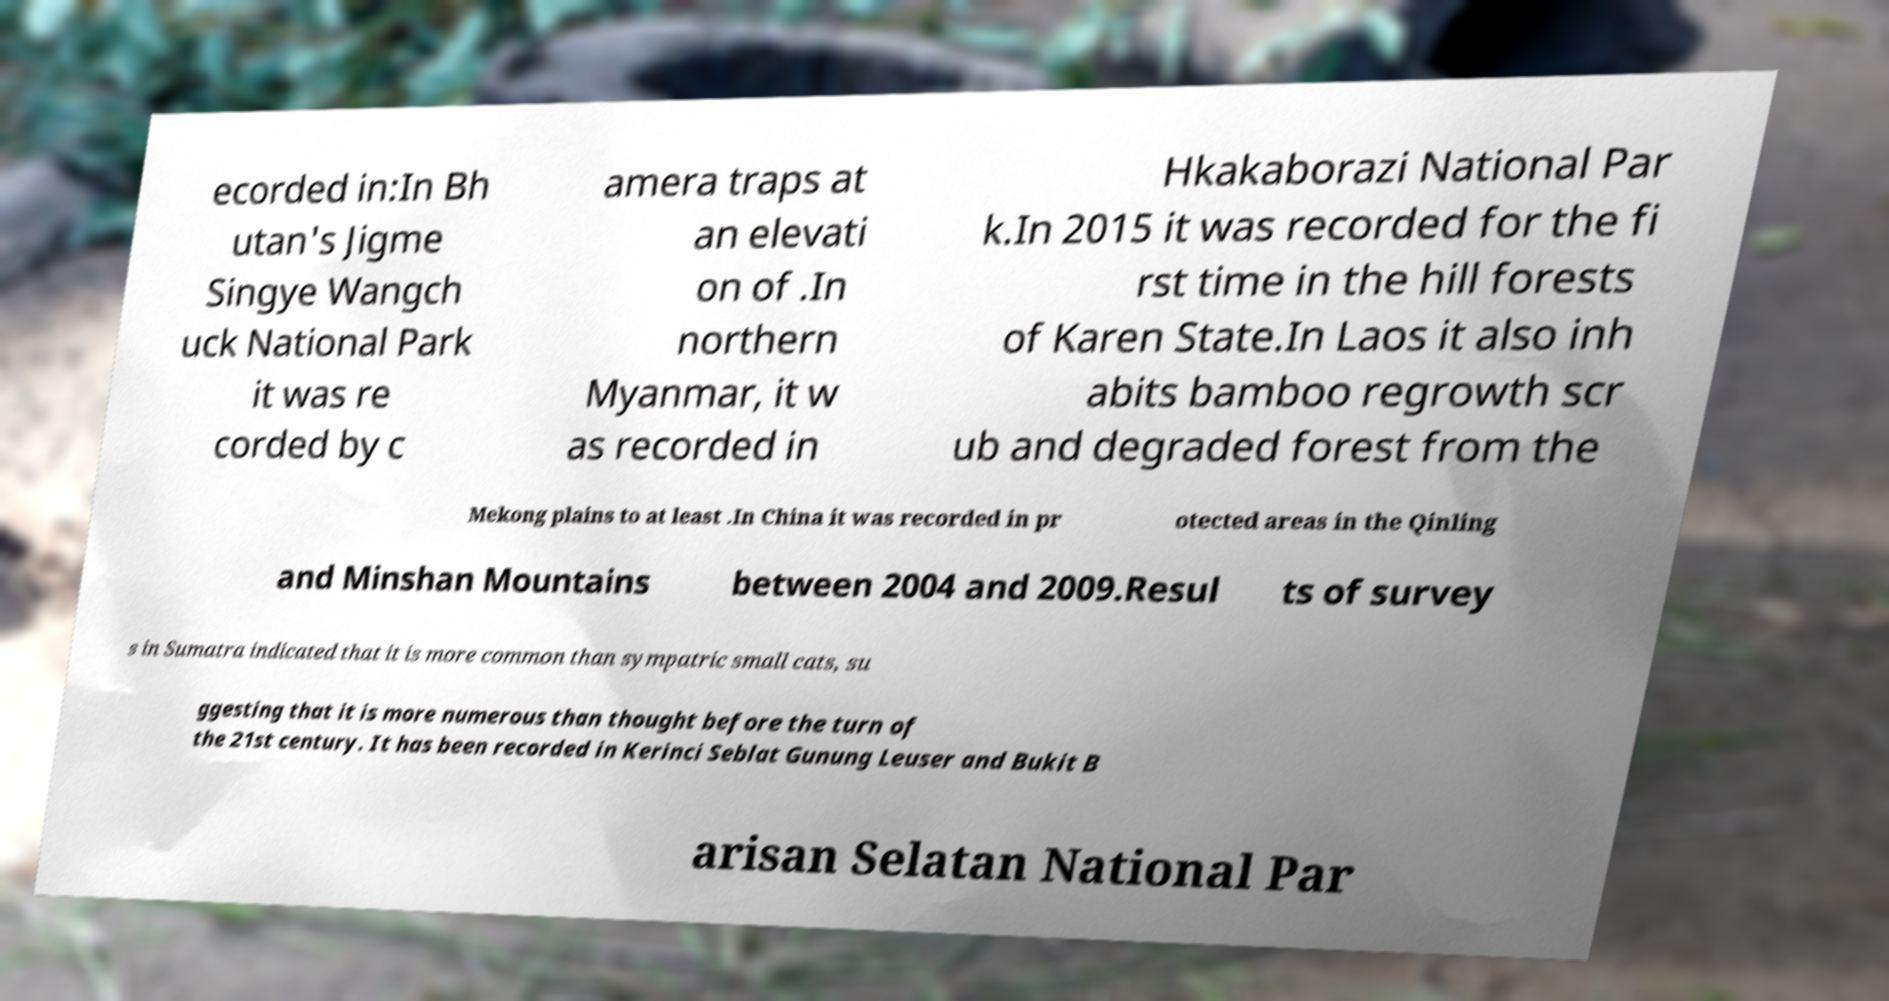Could you assist in decoding the text presented in this image and type it out clearly? ecorded in:In Bh utan's Jigme Singye Wangch uck National Park it was re corded by c amera traps at an elevati on of .In northern Myanmar, it w as recorded in Hkakaborazi National Par k.In 2015 it was recorded for the fi rst time in the hill forests of Karen State.In Laos it also inh abits bamboo regrowth scr ub and degraded forest from the Mekong plains to at least .In China it was recorded in pr otected areas in the Qinling and Minshan Mountains between 2004 and 2009.Resul ts of survey s in Sumatra indicated that it is more common than sympatric small cats, su ggesting that it is more numerous than thought before the turn of the 21st century. It has been recorded in Kerinci Seblat Gunung Leuser and Bukit B arisan Selatan National Par 